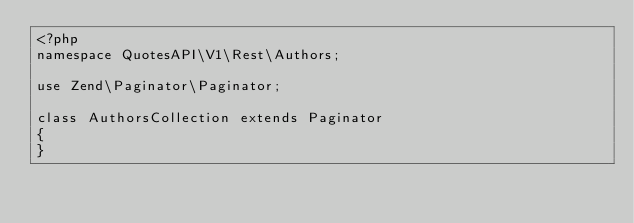<code> <loc_0><loc_0><loc_500><loc_500><_PHP_><?php
namespace QuotesAPI\V1\Rest\Authors;

use Zend\Paginator\Paginator;

class AuthorsCollection extends Paginator
{
}
</code> 